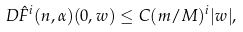Convert formula to latex. <formula><loc_0><loc_0><loc_500><loc_500>D \hat { F } ^ { i } ( n , \alpha ) ( 0 , w ) & \leq C ( m / M ) ^ { i } | w | ,</formula> 